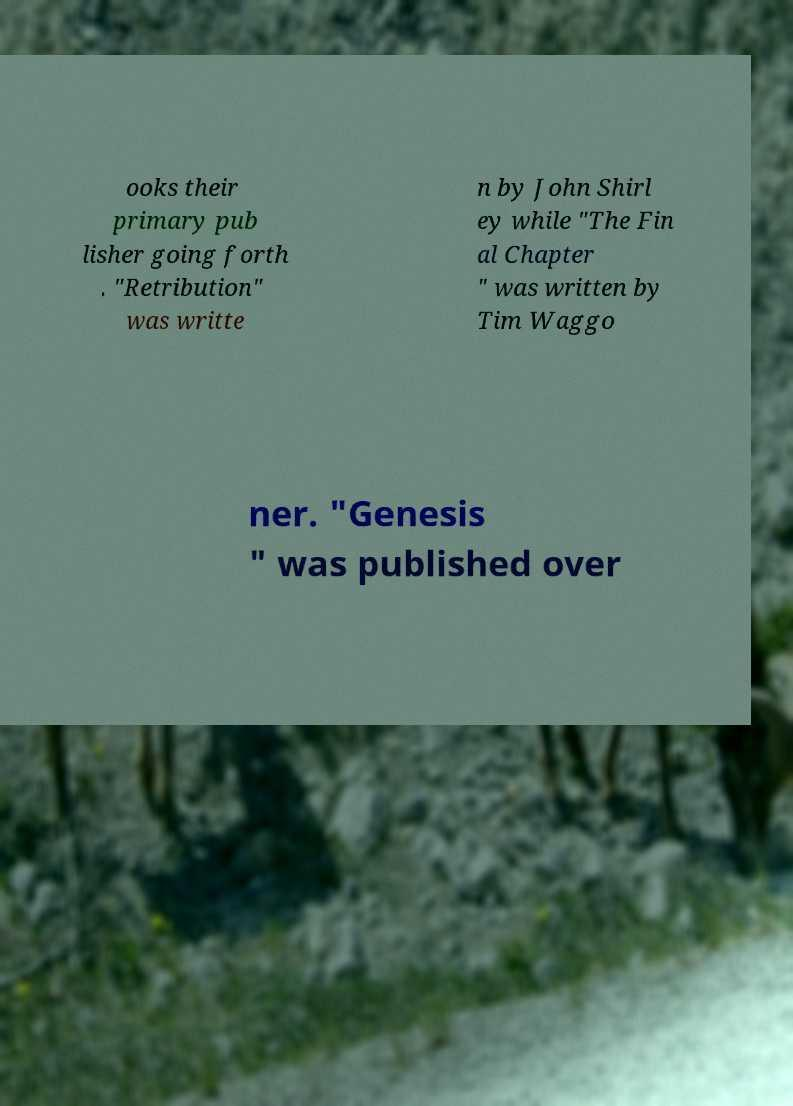Please identify and transcribe the text found in this image. ooks their primary pub lisher going forth . "Retribution" was writte n by John Shirl ey while "The Fin al Chapter " was written by Tim Waggo ner. "Genesis " was published over 